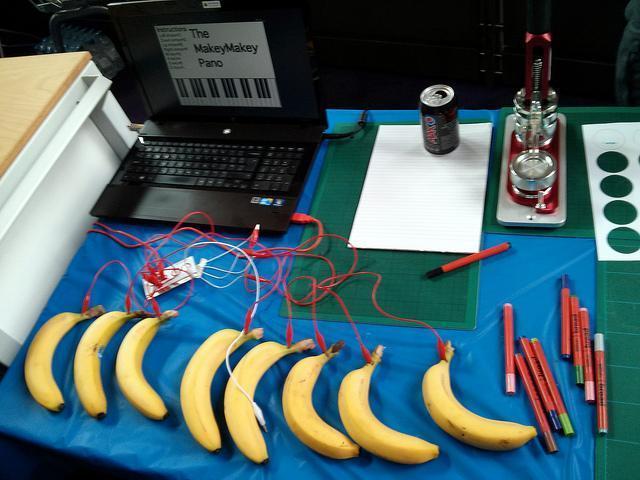How many markers are there?
Give a very brief answer. 9. How many bananas are on the table?
Give a very brief answer. 8. How many bananas are in the picture?
Give a very brief answer. 8. How many laptops are there?
Give a very brief answer. 1. 